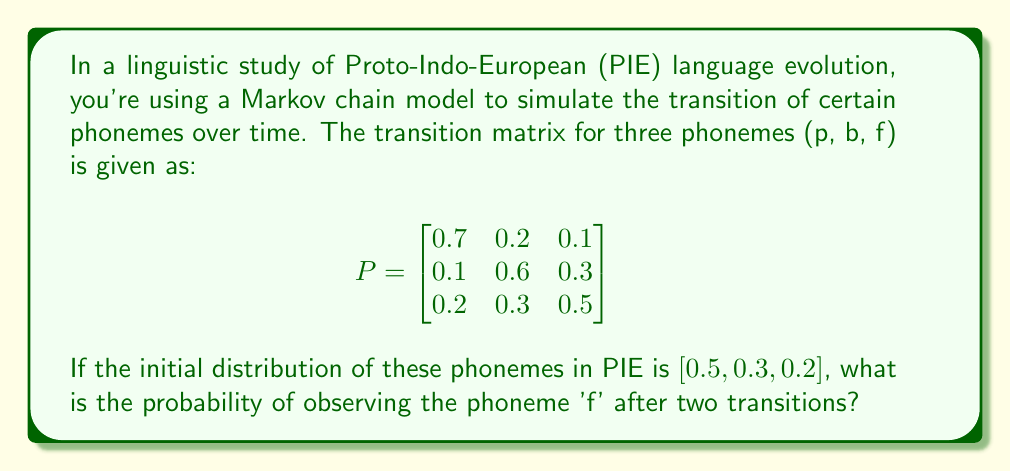Teach me how to tackle this problem. To solve this problem, we'll use the properties of Markov chains and matrix multiplication. Let's break it down step-by-step:

1) The initial distribution is given as $\pi_0 = [0.5, 0.3, 0.2]$.

2) We need to find the distribution after two transitions. This is calculated by multiplying the initial distribution by the transition matrix twice:

   $\pi_2 = \pi_0 P^2$

3) First, let's calculate $P^2$:

   $$
   P^2 = \begin{bmatrix}
   0.7 & 0.2 & 0.1 \\
   0.1 & 0.6 & 0.3 \\
   0.2 & 0.3 & 0.5
   \end{bmatrix} \times 
   \begin{bmatrix}
   0.7 & 0.2 & 0.1 \\
   0.1 & 0.6 & 0.3 \\
   0.2 & 0.3 & 0.5
   \end{bmatrix}
   $$

4) Performing the matrix multiplication:

   $$
   P^2 = \begin{bmatrix}
   0.52 & 0.27 & 0.21 \\
   0.22 & 0.42 & 0.36 \\
   0.31 & 0.39 & 0.30
   \end{bmatrix}
   $$

5) Now, we multiply the initial distribution by $P^2$:

   $\pi_2 = [0.5, 0.3, 0.2] \times 
   \begin{bmatrix}
   0.52 & 0.27 & 0.21 \\
   0.22 & 0.42 & 0.36 \\
   0.31 & 0.39 & 0.30
   \end{bmatrix}$

6) Performing this multiplication:

   $\pi_2 = [0.395, 0.33, 0.275]$

7) The probability of observing 'f' after two transitions is the third element of $\pi_2$, which is 0.275.
Answer: 0.275 